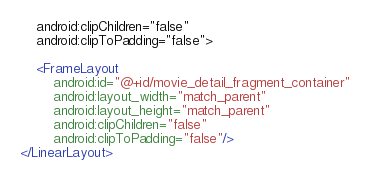<code> <loc_0><loc_0><loc_500><loc_500><_XML_>	android:clipChildren="false"
	android:clipToPadding="false">

	<FrameLayout
		android:id="@+id/movie_detail_fragment_container"
		android:layout_width="match_parent"
		android:layout_height="match_parent"
		android:clipChildren="false"
		android:clipToPadding="false"/>
</LinearLayout></code> 